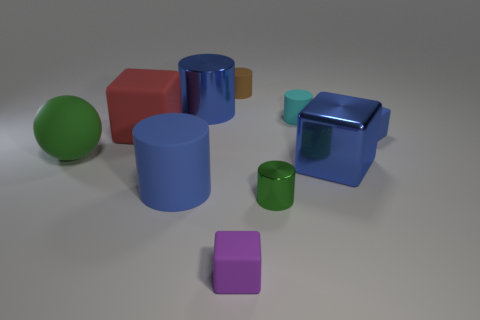There is a small object that is the same color as the shiny block; what shape is it?
Your response must be concise. Cube. What number of big metallic cylinders are the same color as the large metallic cube?
Provide a short and direct response. 1. Is the number of tiny matte cubes behind the rubber sphere greater than the number of tiny green rubber things?
Your answer should be very brief. Yes. There is a red thing; are there any large things in front of it?
Keep it short and to the point. Yes. Is the size of the rubber sphere the same as the red cube?
Provide a succinct answer. Yes. There is another shiny thing that is the same shape as the small purple object; what size is it?
Offer a very short reply. Large. There is a small object that is behind the blue shiny thing behind the small blue rubber thing; what is it made of?
Your answer should be compact. Rubber. Do the large green rubber object and the red thing have the same shape?
Keep it short and to the point. No. What number of objects are on the right side of the purple thing and behind the green cylinder?
Provide a short and direct response. 4. Is the number of metallic cylinders left of the small brown matte cylinder the same as the number of matte cylinders on the right side of the red object?
Provide a short and direct response. No. 